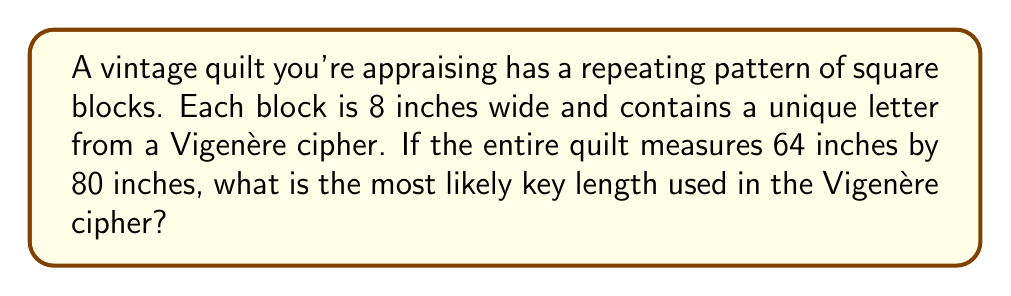Provide a solution to this math problem. Let's approach this step-by-step:

1) First, we need to determine how many blocks are in the quilt:
   - Width of quilt: 64 inches
   - Height of quilt: 80 inches
   - Size of each block: 8 inches

2) Calculate the number of blocks:
   - Blocks across: $\frac{64}{8} = 8$
   - Blocks down: $\frac{80}{8} = 10$
   - Total blocks: $8 \times 10 = 80$

3) In a Vigenère cipher, the key repeats to match the length of the plaintext. The number of blocks should be divisible by the key length.

4) Factors of 80: 1, 2, 4, 5, 8, 10, 16, 20, 40, 80

5) In cryptography, we typically look for the largest reasonable key length. Very short (1, 2) or very long (40, 80) keys are unlikely.

6) Among the remaining options, 8 stands out because:
   - It matches the width of the quilt in blocks
   - It's a common key length in cryptography (byte-sized)

Therefore, the most likely key length is 8.
Answer: 8 